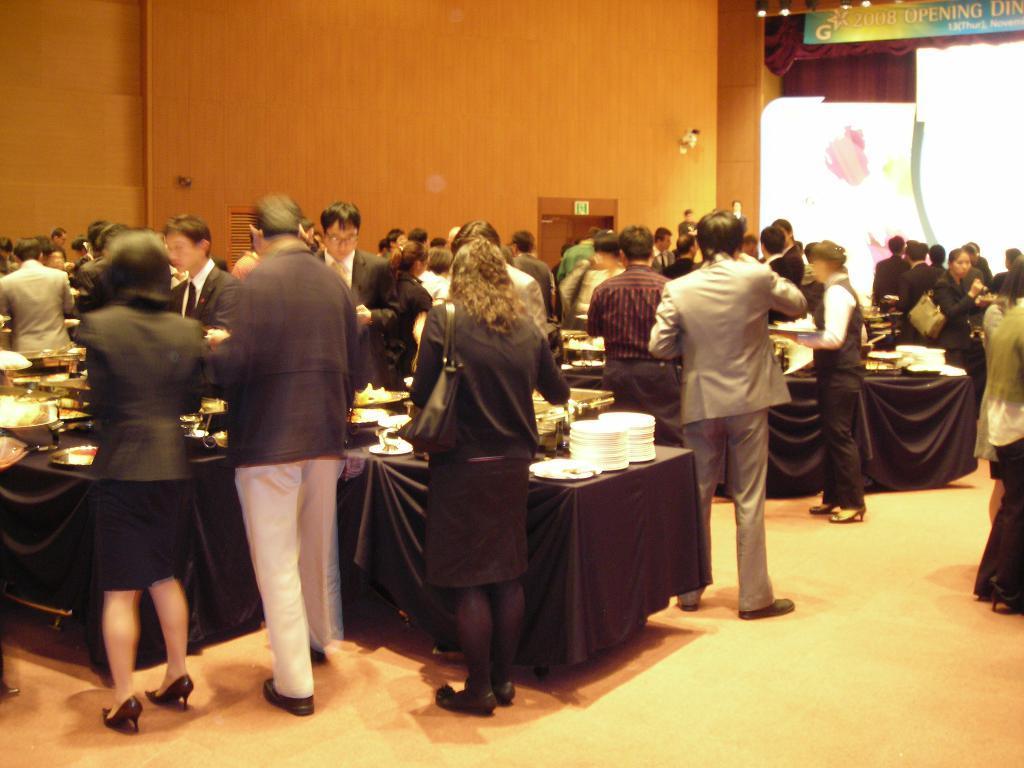Could you give a brief overview of what you see in this image? The image might be taken in a function. In this picture there are people, tables, plates, dishes and various food items. On the right at the top there are curtains, board, lights and other objects. In the center of the background it is wall and there is a door. 